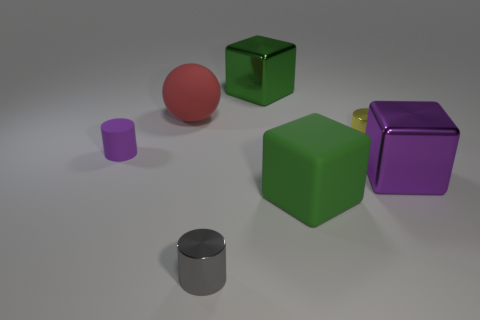What number of cylinders are made of the same material as the big ball?
Make the answer very short. 1. There is a tiny object in front of the green matte thing; is it the same shape as the large purple thing?
Offer a very short reply. No. There is a matte thing left of the rubber ball; what shape is it?
Your answer should be compact. Cylinder. What is the material of the sphere?
Provide a succinct answer. Rubber. The metal block that is the same size as the green metal thing is what color?
Offer a terse response. Purple. There is another thing that is the same color as the small rubber object; what shape is it?
Offer a very short reply. Cube. Is the shape of the green matte thing the same as the big purple metallic thing?
Ensure brevity in your answer.  Yes. The small object that is on the right side of the tiny purple thing and left of the yellow cylinder is made of what material?
Offer a very short reply. Metal. How big is the purple cylinder?
Your answer should be very brief. Small. There is another tiny shiny thing that is the same shape as the yellow shiny object; what is its color?
Make the answer very short. Gray. 